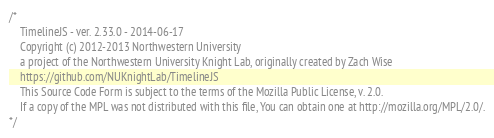<code> <loc_0><loc_0><loc_500><loc_500><_CSS_>/*
    TimelineJS - ver. 2.33.0 - 2014-06-17
    Copyright (c) 2012-2013 Northwestern University
    a project of the Northwestern University Knight Lab, originally created by Zach Wise
    https://github.com/NUKnightLab/TimelineJS
    This Source Code Form is subject to the terms of the Mozilla Public License, v. 2.0.
    If a copy of the MPL was not distributed with this file, You can obtain one at http://mozilla.org/MPL/2.0/.
*/</code> 